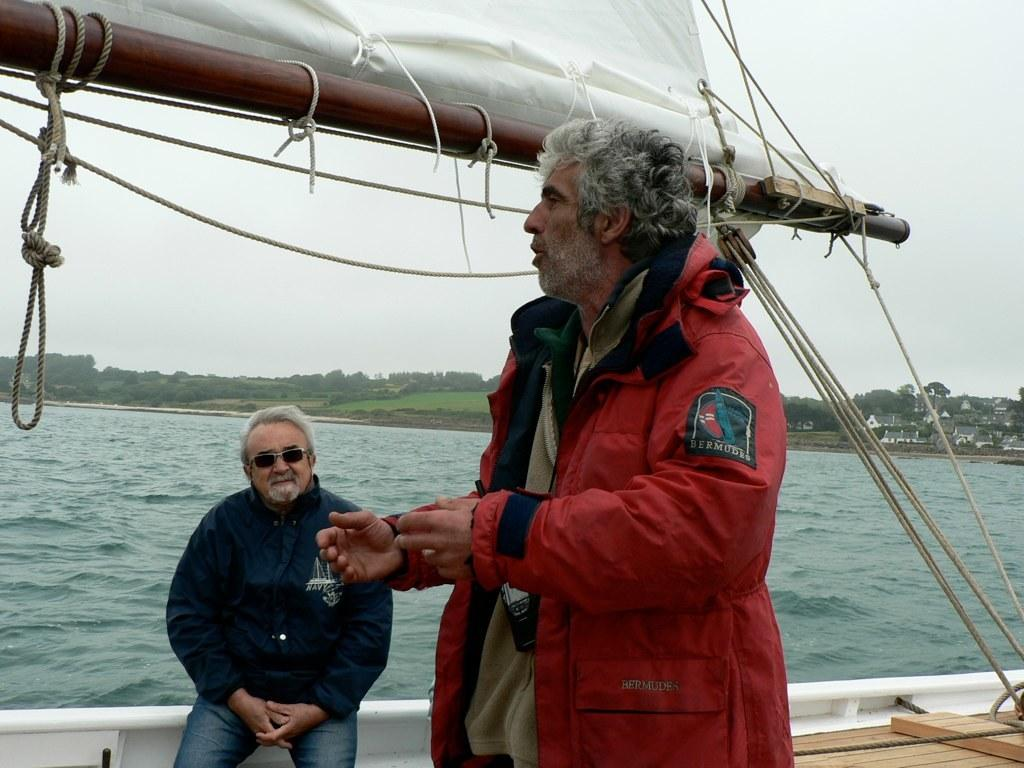<image>
Present a compact description of the photo's key features. Two men on a sailboat, one with a Bermuda patch on his jacket. 